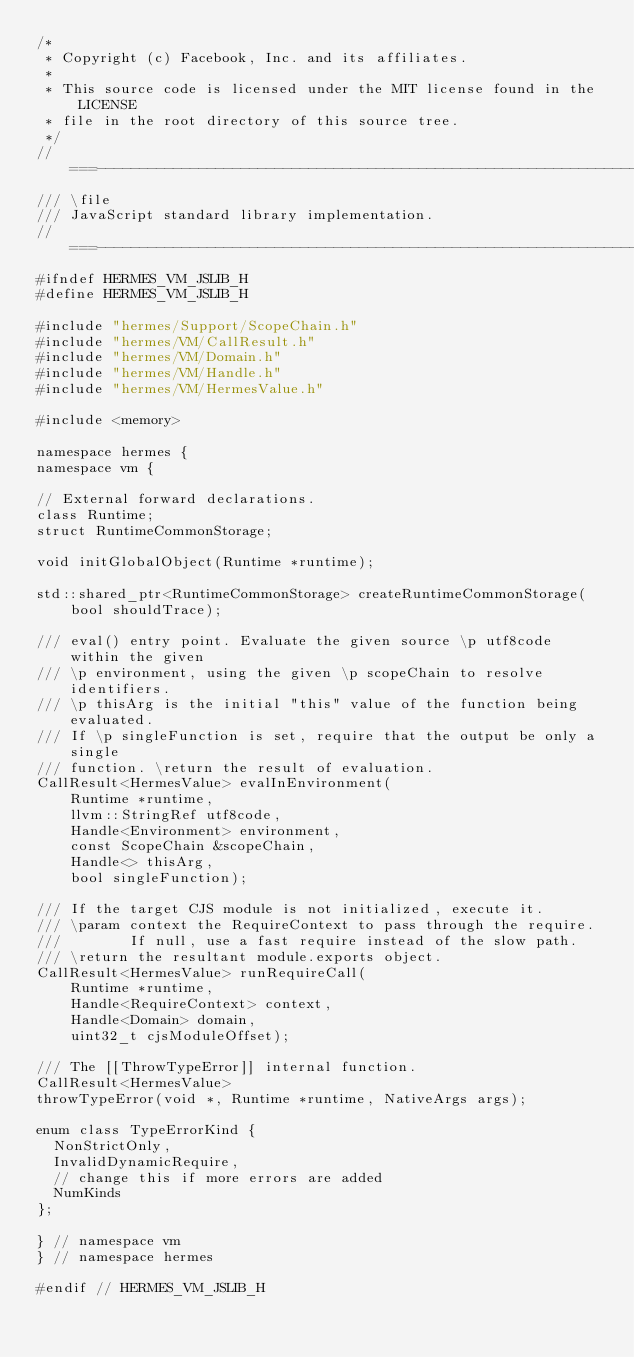Convert code to text. <code><loc_0><loc_0><loc_500><loc_500><_C_>/*
 * Copyright (c) Facebook, Inc. and its affiliates.
 *
 * This source code is licensed under the MIT license found in the LICENSE
 * file in the root directory of this source tree.
 */
//===----------------------------------------------------------------------===//
/// \file
/// JavaScript standard library implementation.
//===----------------------------------------------------------------------===//
#ifndef HERMES_VM_JSLIB_H
#define HERMES_VM_JSLIB_H

#include "hermes/Support/ScopeChain.h"
#include "hermes/VM/CallResult.h"
#include "hermes/VM/Domain.h"
#include "hermes/VM/Handle.h"
#include "hermes/VM/HermesValue.h"

#include <memory>

namespace hermes {
namespace vm {

// External forward declarations.
class Runtime;
struct RuntimeCommonStorage;

void initGlobalObject(Runtime *runtime);

std::shared_ptr<RuntimeCommonStorage> createRuntimeCommonStorage(
    bool shouldTrace);

/// eval() entry point. Evaluate the given source \p utf8code within the given
/// \p environment, using the given \p scopeChain to resolve identifiers.
/// \p thisArg is the initial "this" value of the function being evaluated.
/// If \p singleFunction is set, require that the output be only a single
/// function. \return the result of evaluation.
CallResult<HermesValue> evalInEnvironment(
    Runtime *runtime,
    llvm::StringRef utf8code,
    Handle<Environment> environment,
    const ScopeChain &scopeChain,
    Handle<> thisArg,
    bool singleFunction);

/// If the target CJS module is not initialized, execute it.
/// \param context the RequireContext to pass through the require.
///        If null, use a fast require instead of the slow path.
/// \return the resultant module.exports object.
CallResult<HermesValue> runRequireCall(
    Runtime *runtime,
    Handle<RequireContext> context,
    Handle<Domain> domain,
    uint32_t cjsModuleOffset);

/// The [[ThrowTypeError]] internal function.
CallResult<HermesValue>
throwTypeError(void *, Runtime *runtime, NativeArgs args);

enum class TypeErrorKind {
  NonStrictOnly,
  InvalidDynamicRequire,
  // change this if more errors are added
  NumKinds
};

} // namespace vm
} // namespace hermes

#endif // HERMES_VM_JSLIB_H
</code> 